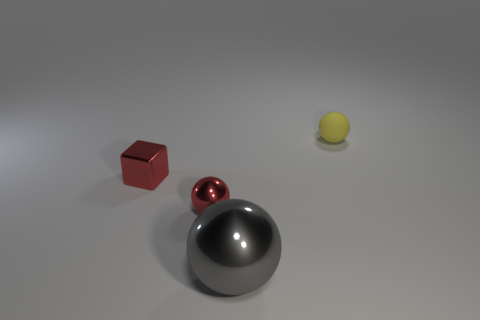Is there anything else that has the same size as the gray object?
Offer a terse response. No. How many yellow cylinders are there?
Provide a short and direct response. 0. What color is the cube that is the same size as the red shiny sphere?
Make the answer very short. Red. Do the matte thing and the red cube have the same size?
Ensure brevity in your answer.  Yes. What is the shape of the object that is the same color as the metallic cube?
Provide a succinct answer. Sphere. There is a rubber object; is it the same size as the red thing to the right of the red block?
Ensure brevity in your answer.  Yes. What is the color of the metallic thing that is both to the left of the big gray metal object and to the right of the red block?
Your response must be concise. Red. Are there more things right of the gray object than tiny red shiny objects that are behind the small yellow matte thing?
Keep it short and to the point. Yes. What size is the gray object that is made of the same material as the small block?
Keep it short and to the point. Large. There is a matte ball that is behind the tiny red shiny cube; how many large things are in front of it?
Your answer should be compact. 1. 